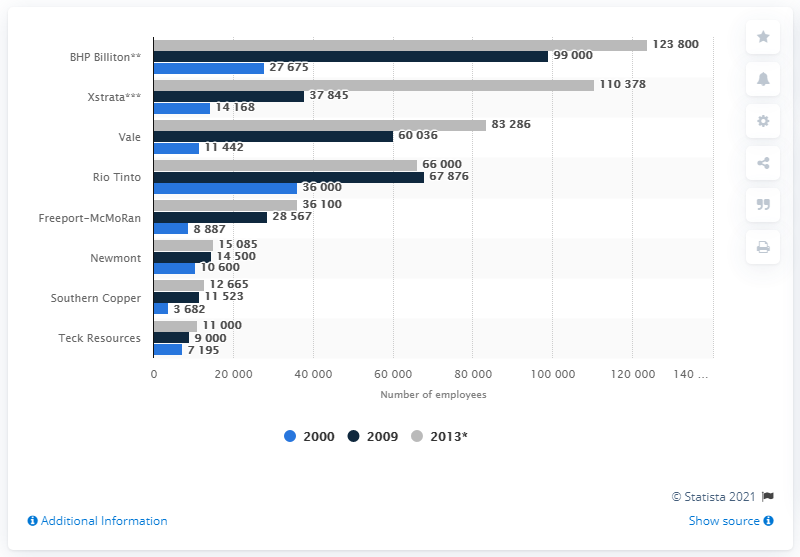Specify some key components in this picture. In 2009, BHP Billiton employed approximately 99,000 people. 